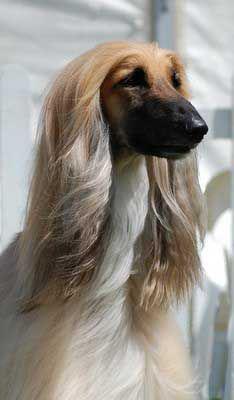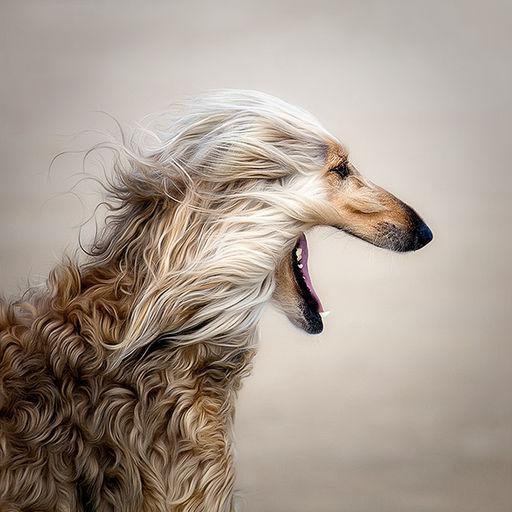The first image is the image on the left, the second image is the image on the right. Examine the images to the left and right. Is the description "there us a dog wearing a necklace draped on it's neck" accurate? Answer yes or no. No. The first image is the image on the left, the second image is the image on the right. Evaluate the accuracy of this statement regarding the images: "One of the dogs is wearing jewelry.". Is it true? Answer yes or no. No. 